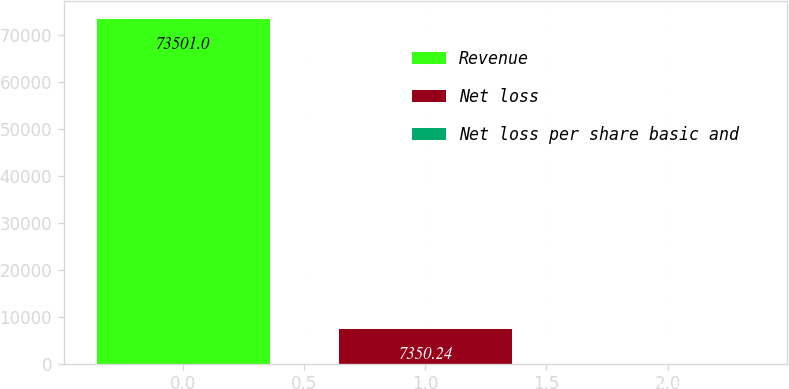Convert chart. <chart><loc_0><loc_0><loc_500><loc_500><bar_chart><fcel>Revenue<fcel>Net loss<fcel>Net loss per share basic and<nl><fcel>73501<fcel>7350.24<fcel>0.15<nl></chart> 